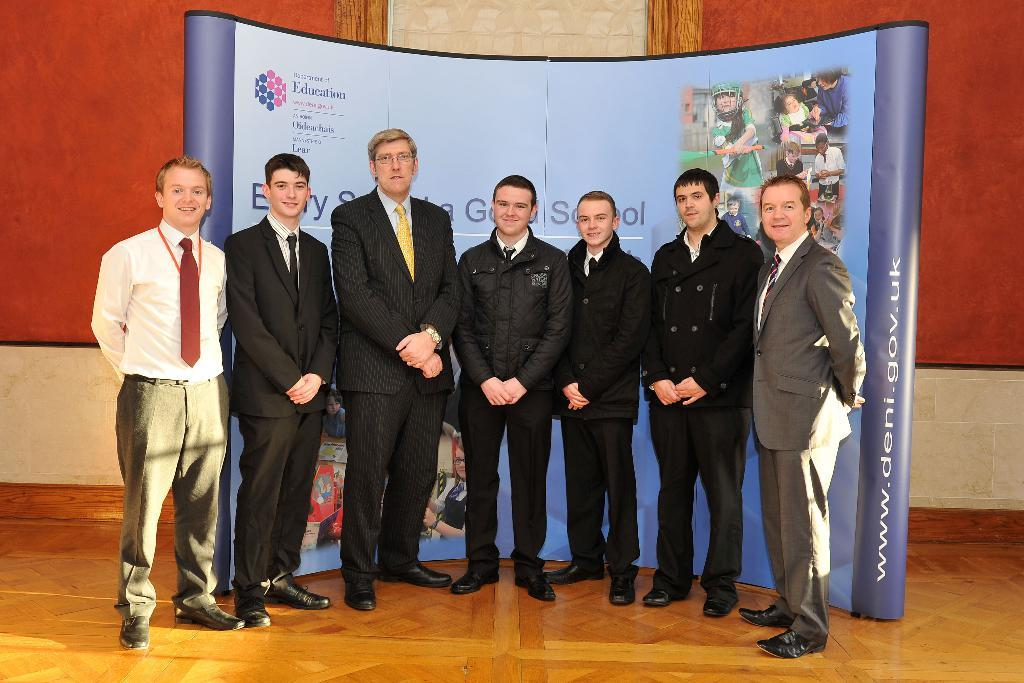How many people are in the image? There is a group of people in the image, but the exact number is not specified. Where are the people standing in the image? The people are standing on a path in the image. What can be seen in the background of the image? There is a board and a wall in the background of the image. How many mice are hiding behind the board in the image? There are no mice present in the image, so it is not possible to determine how many might be hiding behind the board. 